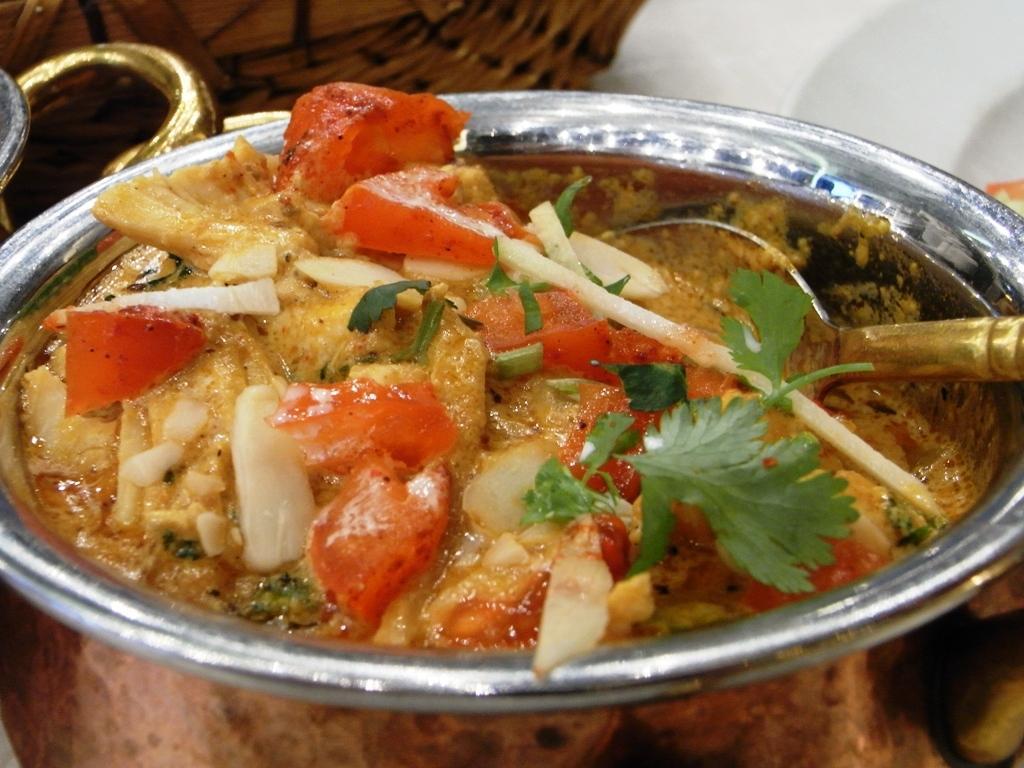How would you summarize this image in a sentence or two? In this picture I can see a food item with a spoon in a copper bowl, and in the background there are some objects. 